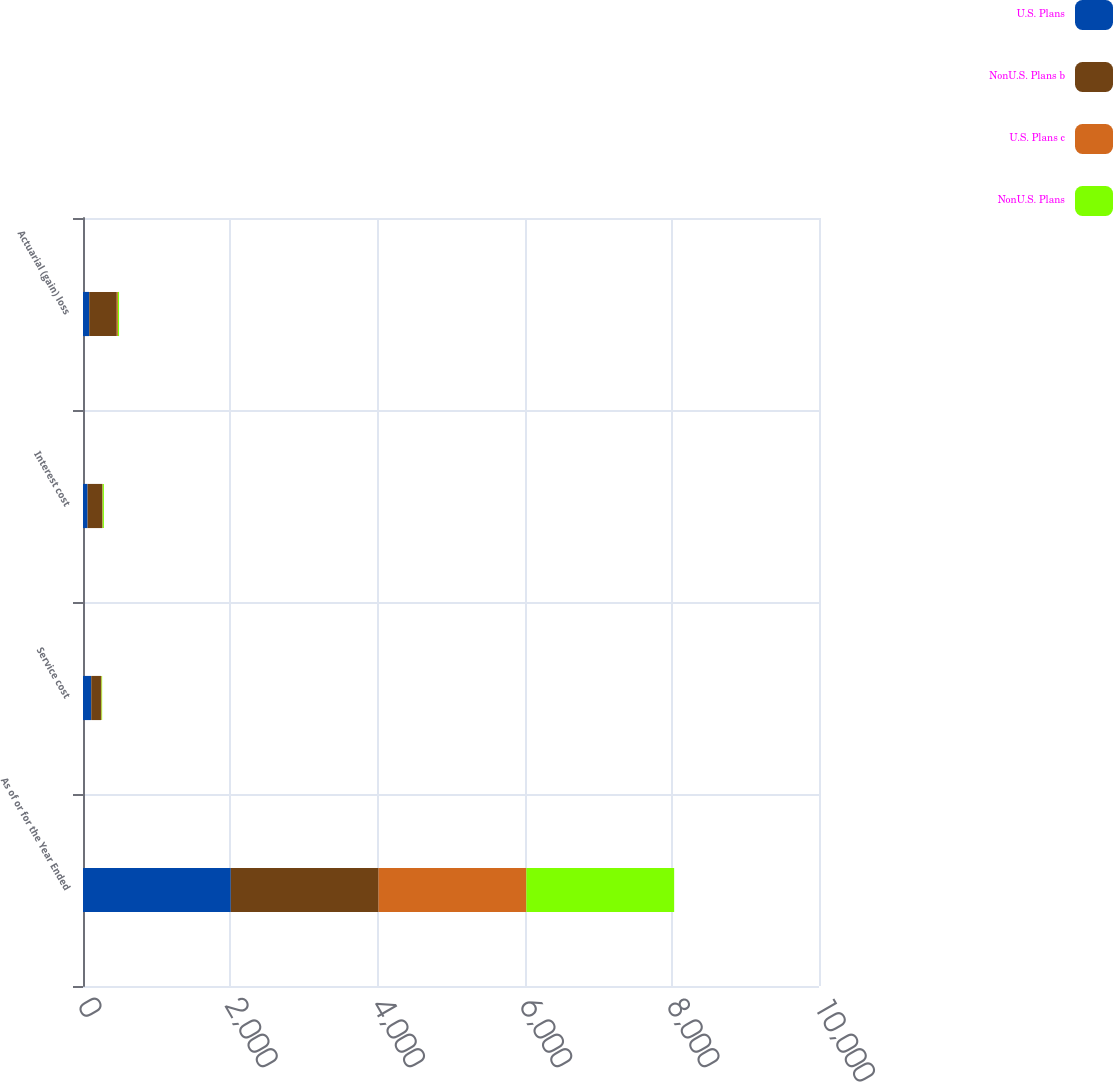Convert chart. <chart><loc_0><loc_0><loc_500><loc_500><stacked_bar_chart><ecel><fcel>As of or for the Year Ended<fcel>Service cost<fcel>Interest cost<fcel>Actuarial (gain) loss<nl><fcel>U.S. Plans<fcel>2008<fcel>112<fcel>62<fcel>85<nl><fcel>NonU.S. Plans b<fcel>2008<fcel>132<fcel>202<fcel>374<nl><fcel>U.S. Plans c<fcel>2008<fcel>8<fcel>4<fcel>15<nl><fcel>NonU.S. Plans<fcel>2008<fcel>8<fcel>16<fcel>16<nl></chart> 